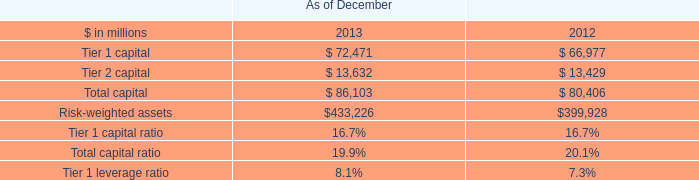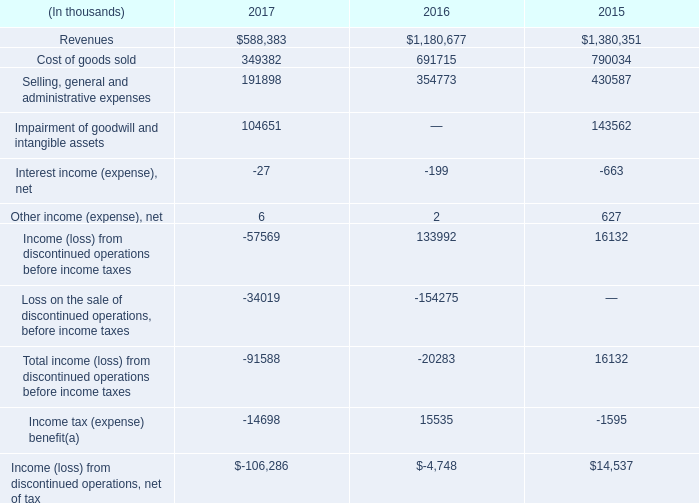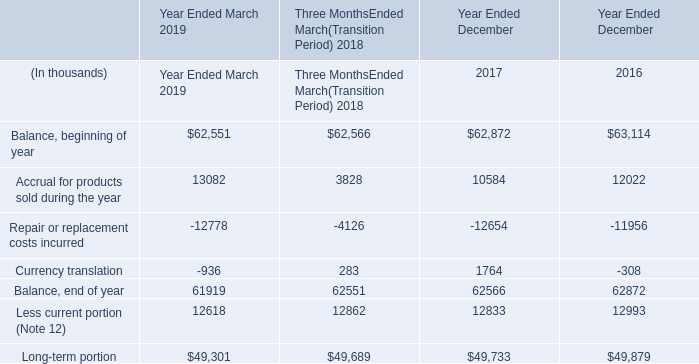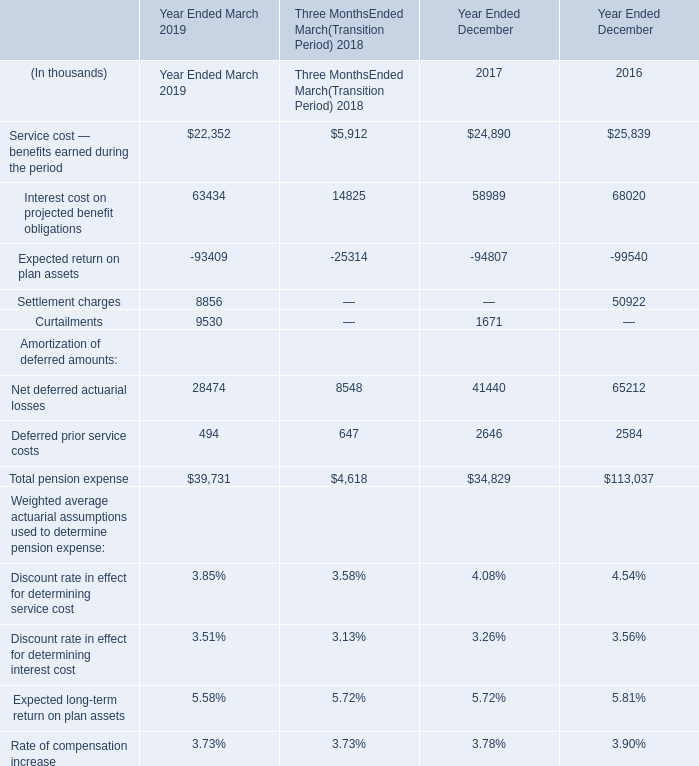How much of Balance is there in total (in year ended March 2019) without Repair or replacement costs incurred and Currency translation? (in thousand) 
Computations: (62551 + 13082)
Answer: 75633.0. 